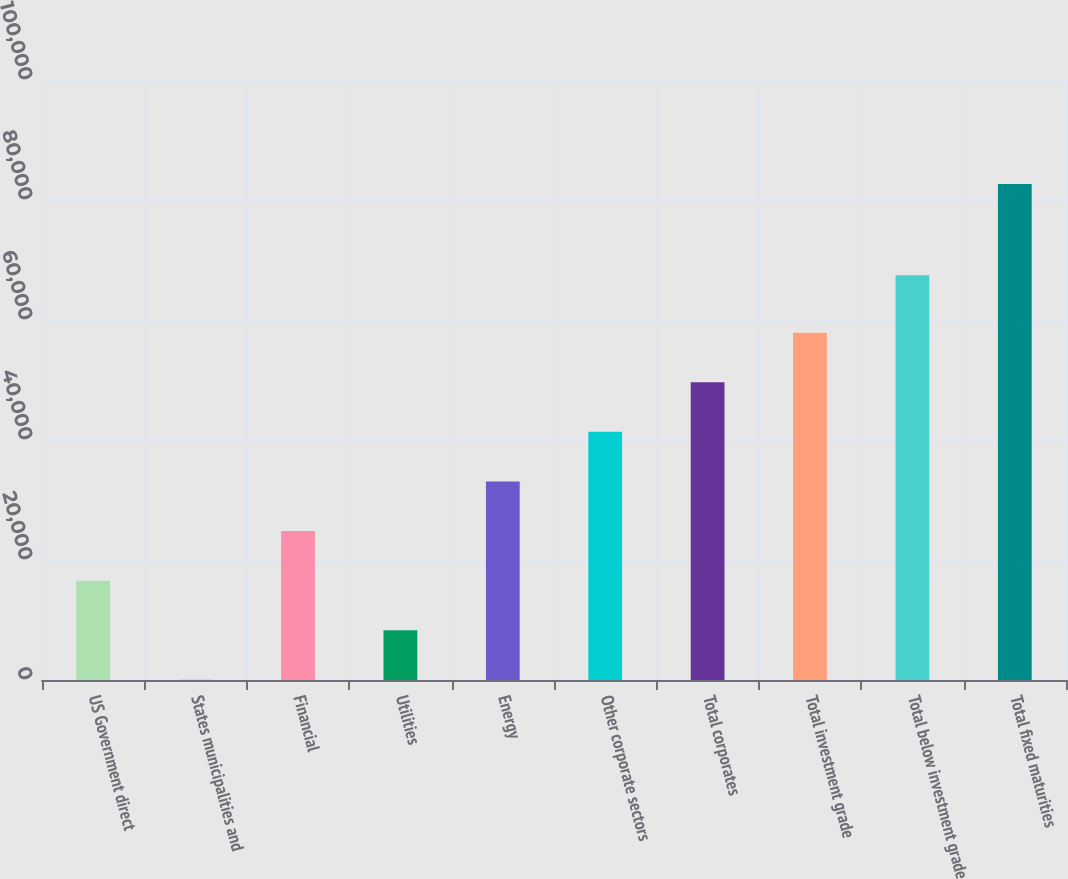Convert chart. <chart><loc_0><loc_0><loc_500><loc_500><bar_chart><fcel>US Government direct<fcel>States municipalities and<fcel>Financial<fcel>Utilities<fcel>Energy<fcel>Other corporate sectors<fcel>Total corporates<fcel>Total investment grade<fcel>Total below investment grade<fcel>Total fixed maturities<nl><fcel>16560.6<fcel>30<fcel>24825.9<fcel>8295.3<fcel>33091.2<fcel>41356.5<fcel>49621.8<fcel>57887.1<fcel>67472<fcel>82683<nl></chart> 